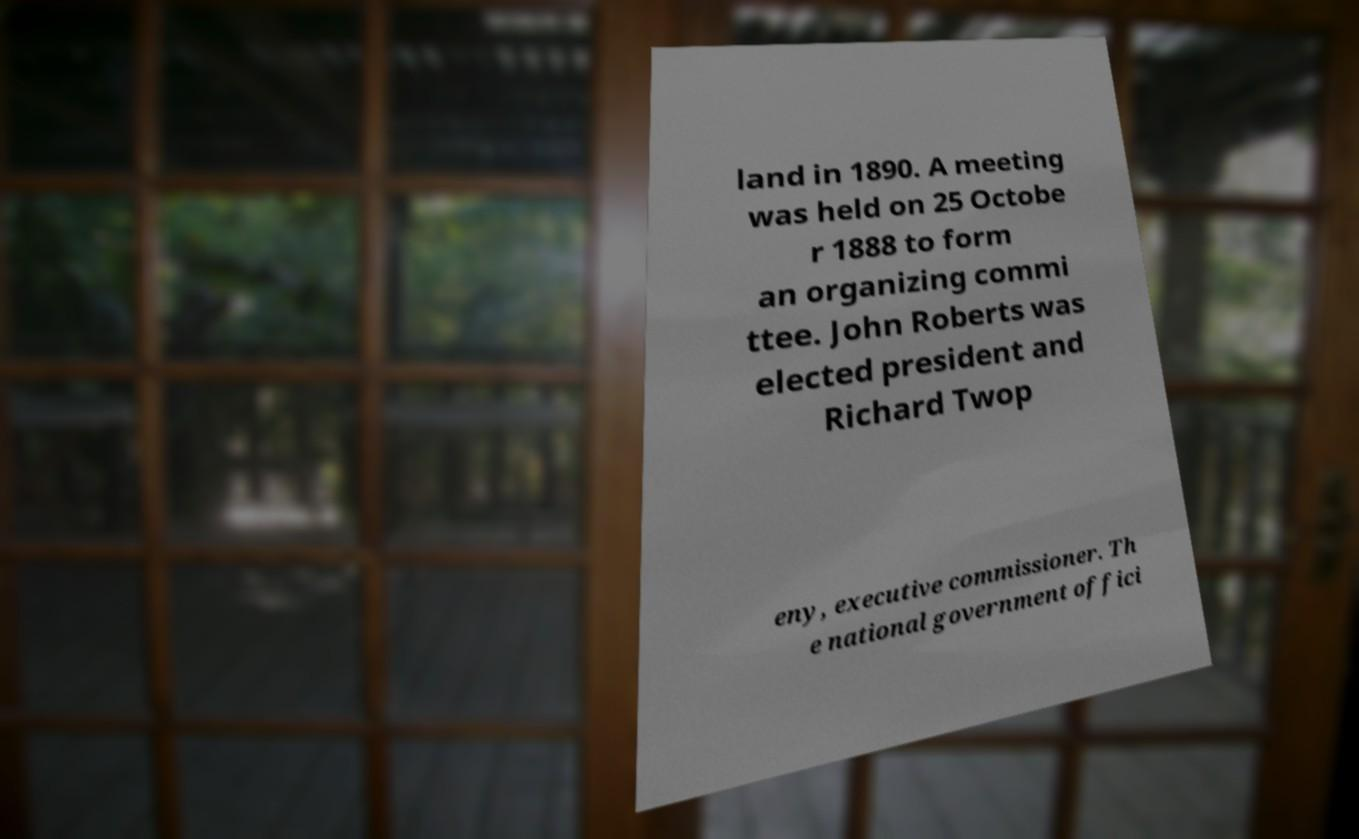Could you assist in decoding the text presented in this image and type it out clearly? land in 1890. A meeting was held on 25 Octobe r 1888 to form an organizing commi ttee. John Roberts was elected president and Richard Twop eny, executive commissioner. Th e national government offici 